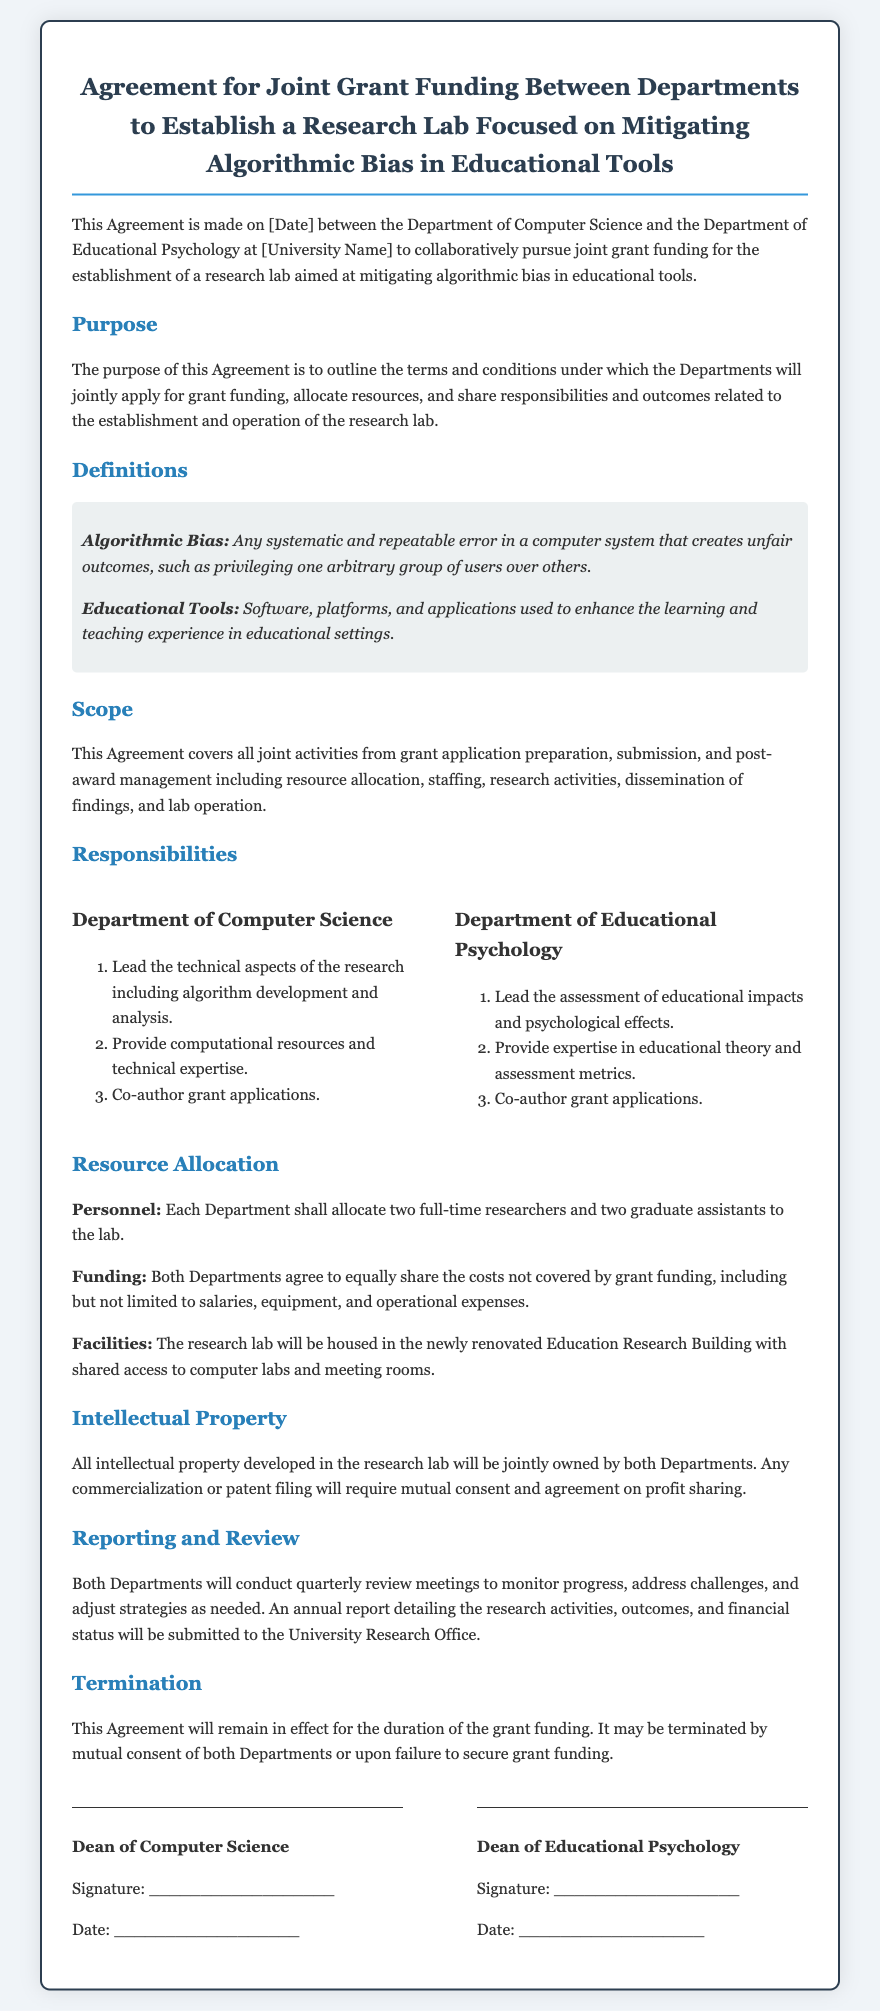What is the purpose of this Agreement? The purpose of the Agreement is to outline the terms and conditions under which the Departments will jointly apply for grant funding, allocate resources, and share responsibilities and outcomes related to the establishment and operation of the research lab.
Answer: Outline terms and conditions What are the two departments involved in this Agreement? The two departments involved in this Agreement are the Department of Computer Science and the Department of Educational Psychology.
Answer: Department of Computer Science and the Department of Educational Psychology How many full-time researchers will each Department allocate to the lab? Each Department shall allocate two full-time researchers to the lab, as stated in the Resource Allocation section.
Answer: Two full-time researchers What will be jointly owned by both Departments? All intellectual property developed in the research lab will be jointly owned.
Answer: All intellectual property When will the annual report be submitted to the University Research Office? The annual report detailing the research activities, outcomes, and financial status will be submitted annually, after conducting quarterly review meetings.
Answer: Annually How may this Agreement be terminated? This Agreement may be terminated by mutual consent of both Departments or upon failure to secure grant funding.
Answer: Mutual consent or failure to secure grant funding What will the research lab focus on? The research lab will focus on mitigating algorithmic bias in educational tools.
Answer: Mitigating algorithmic bias in educational tools What is one responsibility of the Department of Educational Psychology? One responsibility of the Department of Educational Psychology is to lead the assessment of educational impacts and psychological effects.
Answer: Lead the assessment of educational impacts and psychological effects 